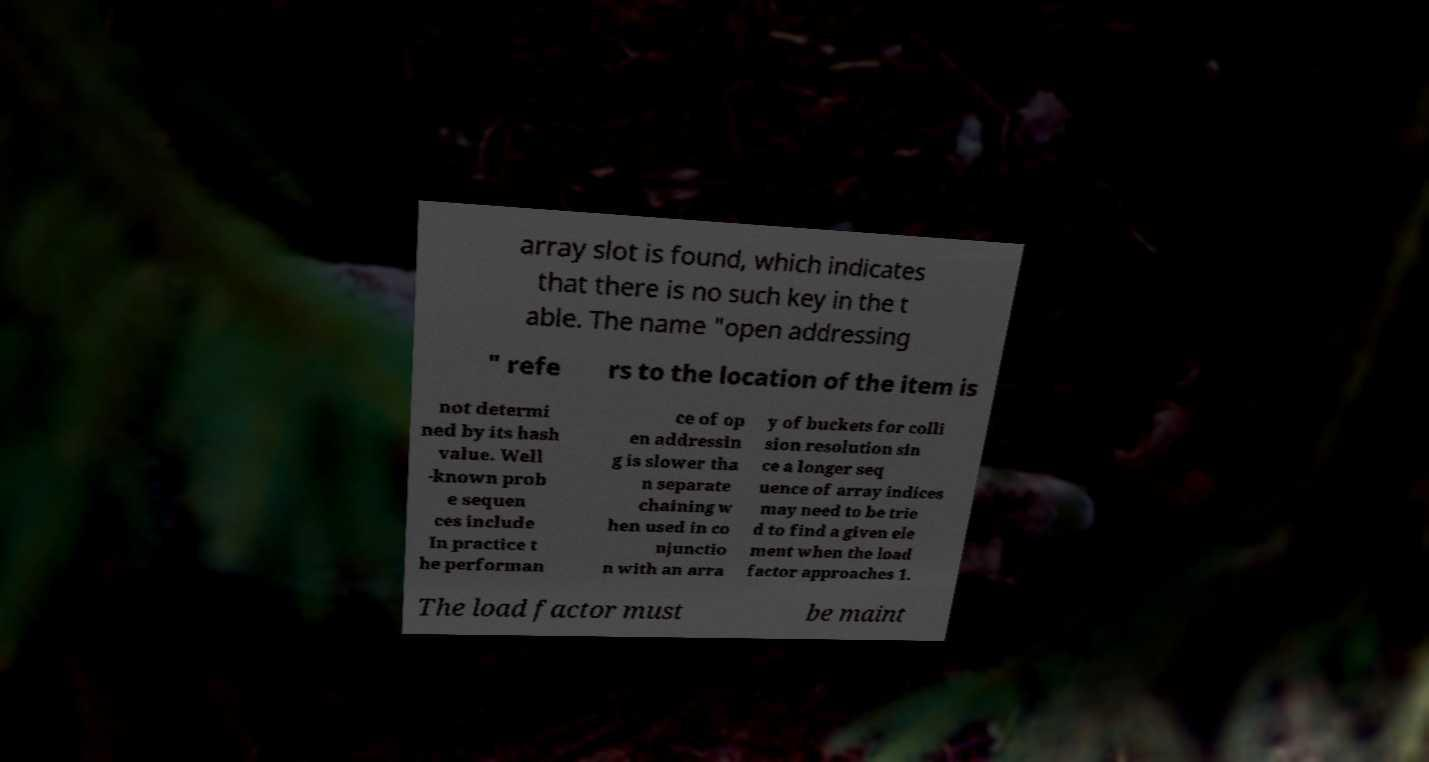What messages or text are displayed in this image? I need them in a readable, typed format. array slot is found, which indicates that there is no such key in the t able. The name "open addressing " refe rs to the location of the item is not determi ned by its hash value. Well -known prob e sequen ces include In practice t he performan ce of op en addressin g is slower tha n separate chaining w hen used in co njunctio n with an arra y of buckets for colli sion resolution sin ce a longer seq uence of array indices may need to be trie d to find a given ele ment when the load factor approaches 1. The load factor must be maint 